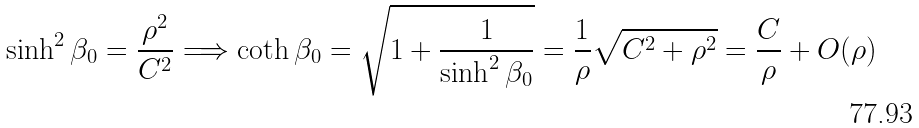<formula> <loc_0><loc_0><loc_500><loc_500>\sinh ^ { 2 } \beta _ { 0 } & = \frac { \rho ^ { 2 } } { C ^ { 2 } } \Longrightarrow \coth \beta _ { 0 } = \sqrt { 1 + \frac { 1 } { \sinh ^ { 2 } \beta _ { 0 } } } = \frac { 1 } { \rho } \sqrt { C ^ { 2 } + \rho ^ { 2 } } = \frac { C } { \rho } + O ( \rho )</formula> 